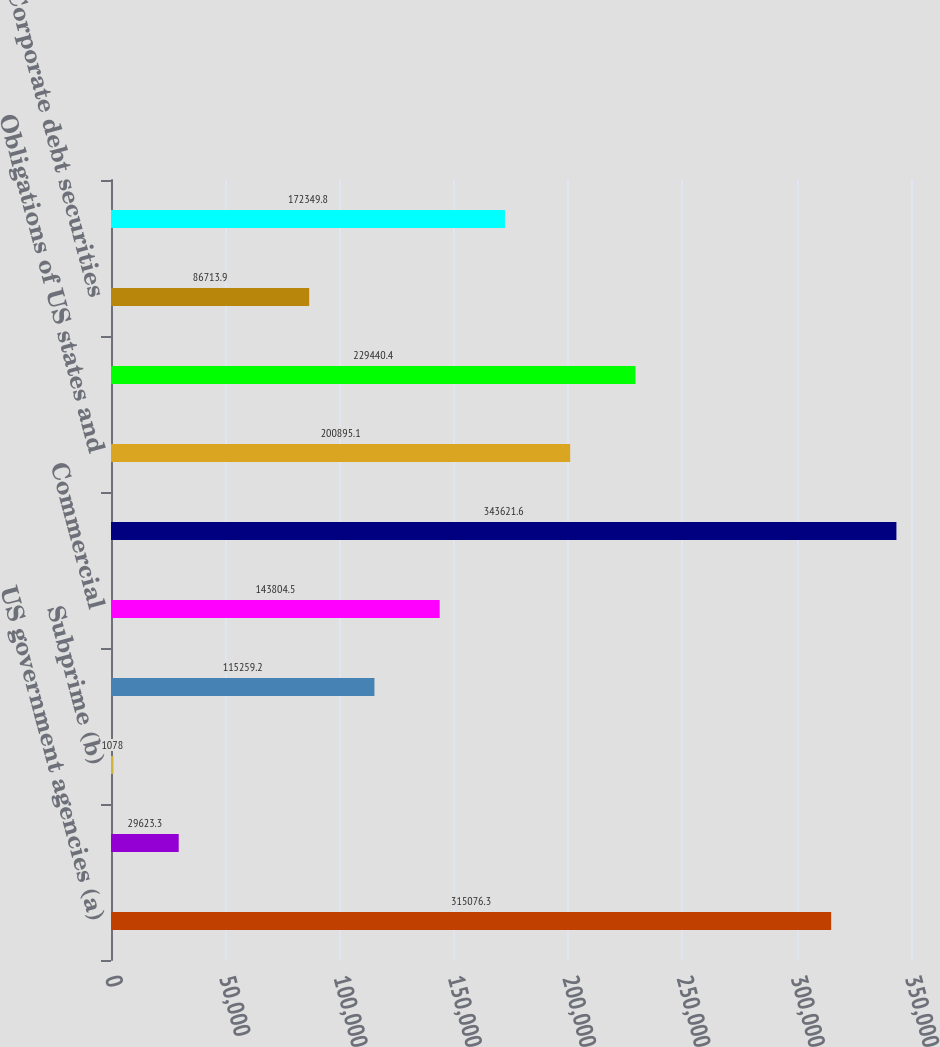<chart> <loc_0><loc_0><loc_500><loc_500><bar_chart><fcel>US government agencies (a)<fcel>Prime and Alt-A (b)<fcel>Subprime (b)<fcel>Non-US<fcel>Commercial<fcel>Total mortgage-backed<fcel>Obligations of US states and<fcel>Non-US government debt<fcel>Corporate debt securities<fcel>Collateralized loan<nl><fcel>315076<fcel>29623.3<fcel>1078<fcel>115259<fcel>143804<fcel>343622<fcel>200895<fcel>229440<fcel>86713.9<fcel>172350<nl></chart> 